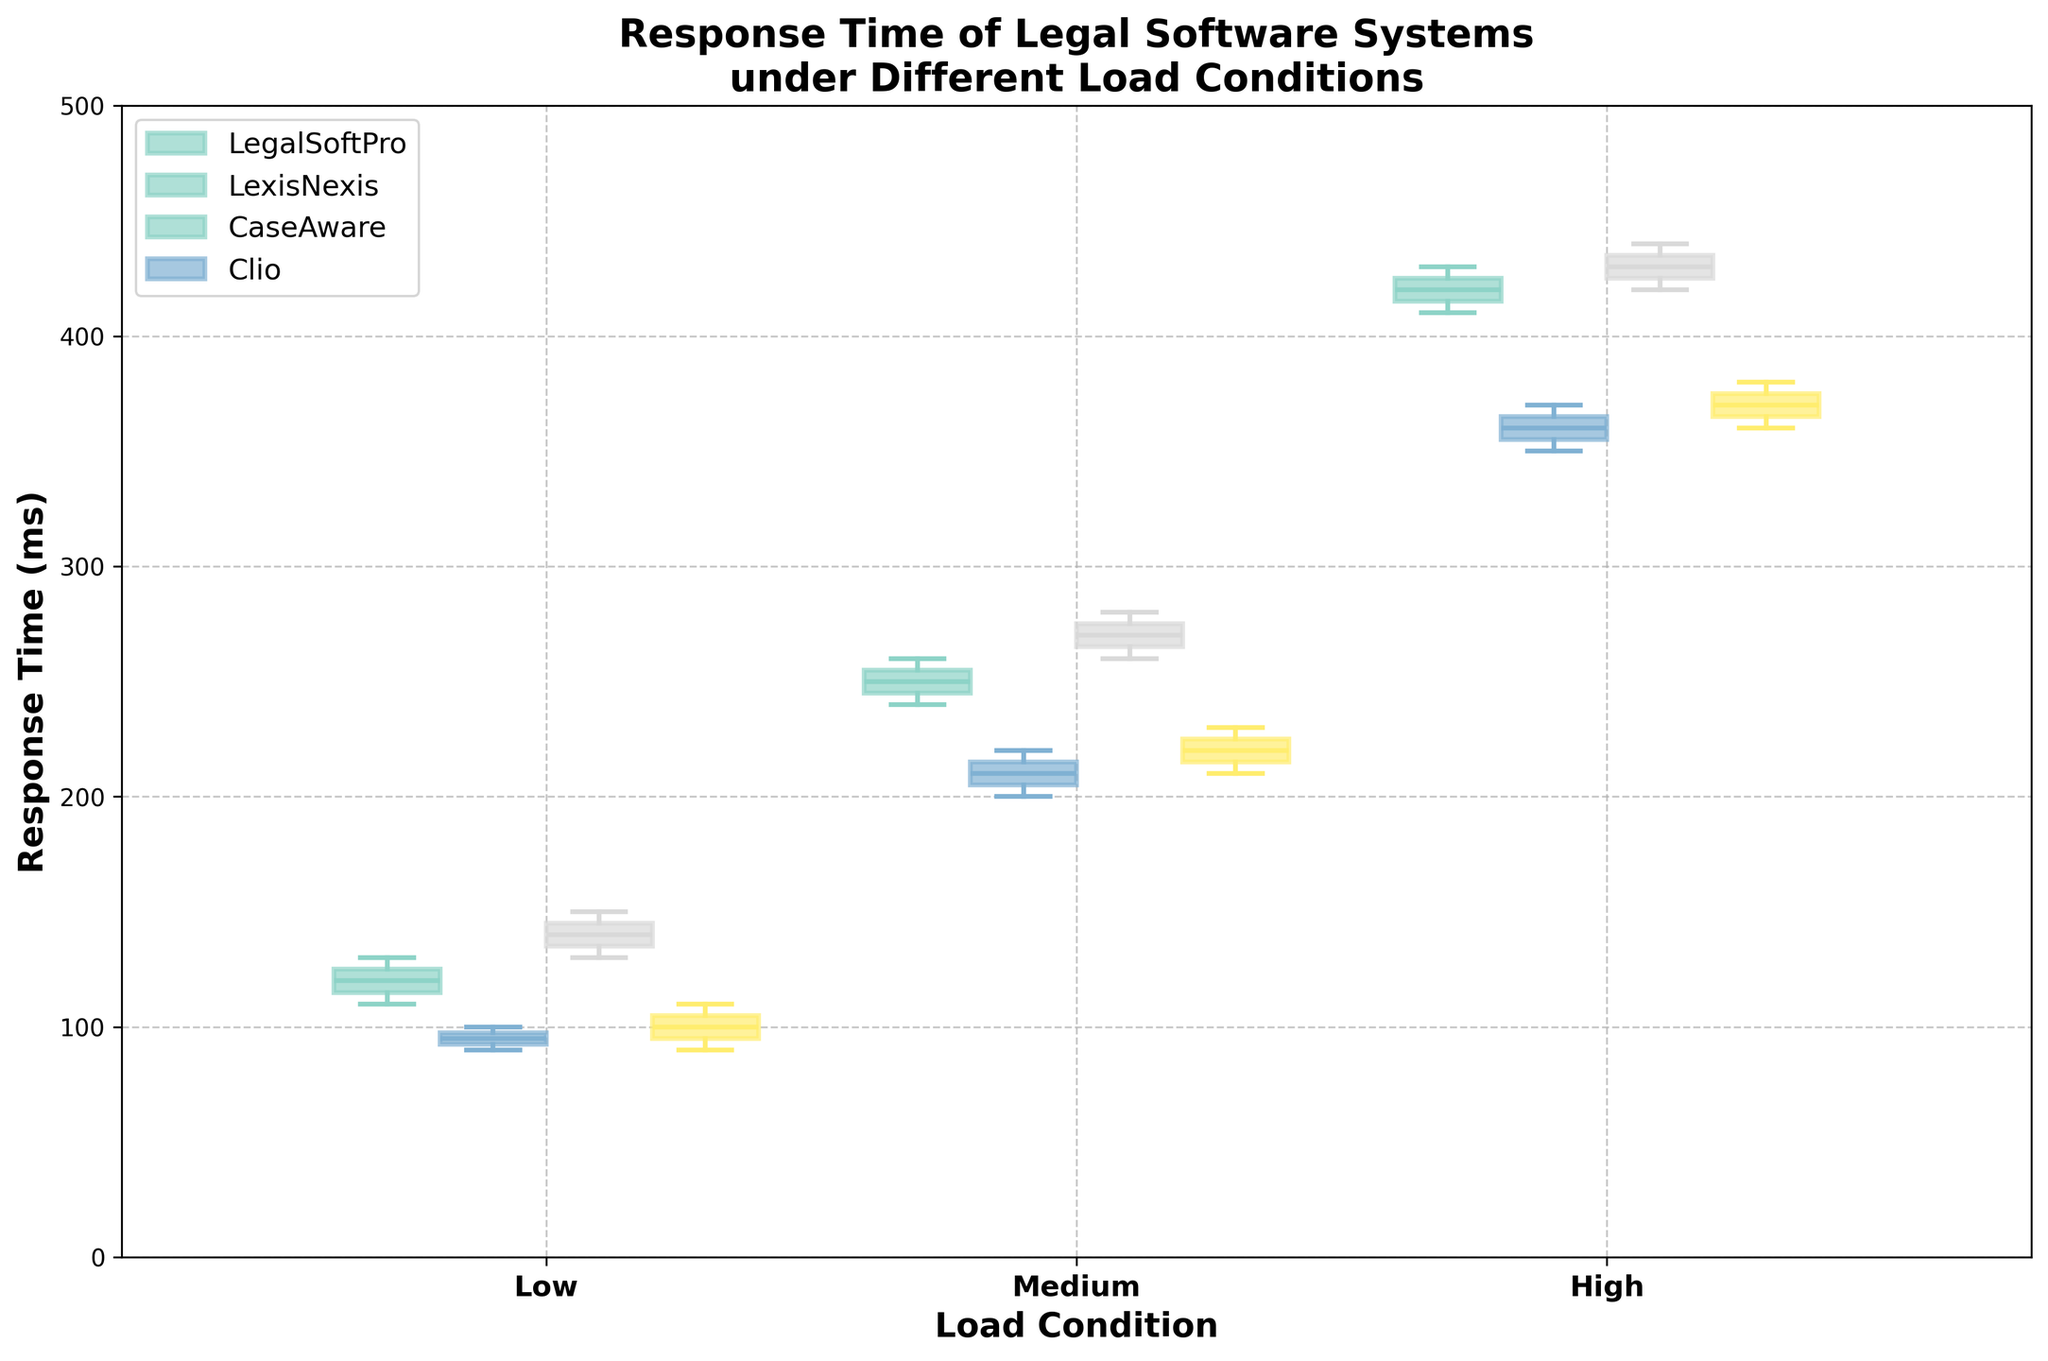How many load conditions are shown in the plot? There are three distinct load conditions shown on the x-axis: Low, Medium, and High.
Answer: 3 Which system has the lowest median response time under Low load condition? The box for LexisNexis is positioned lowest among others under Low load condition, indicating it has the lowest median response time.
Answer: LexisNexis What is the interquartile range (IQR) for LegalSoftPro under Medium load condition? The IQR is calculated by subtracting the lower quartile (Q1) from the upper quartile (Q3). For LegalSoftPro, Q1 is around 240ms and Q3 is about 260ms. The IQR is 260 - 240.
Answer: 20ms Which system shows the greatest increase in median response time from Low to High load condition? By examining the middle line of each box plot for each load condition, LegalSoftPro shows the greatest increase in height from Low to High conditions compared to others.
Answer: LegalSoftPro How do the spread of response times for CaseAware under High load condition compare to other systems? CaseAware's box plot for High load condition is larger in height relative to others, indicating a greater spread or variability in response times.
Answer: Larger spread Which system shows the most consistent response times under Medium load condition? LexisNexis has the smallest spread (i.e., shortest box) under Medium load condition, indicating the most consistent response times.
Answer: LexisNexis Is there an overlap in the response time range between Medium and High load conditions for LegalSoftPro? Upon examining, the whiskers of LegalSoftPro's Medium load box plot touch the lower whisker of the High load box plot, showing some overlap in response time ranges.
Answer: Yes Which system has the highest median response time under High load condition? By observing the position of the median line in each High load box plot, LegalSoftPro has the highest median response time among others.
Answer: LegalSoftPro What’s the difference in median response time between Clio and CaseAware under High load condition? The median lines under High load for Clio and CaseAware are around 370ms and 430ms, respectively. The difference is 430 - 370.
Answer: 60ms Has any system maintained a consistent median response time across different load conditions? No system maintains a consistent median response time as all show notable changes in the median line across Low, Medium, and High load conditions.
Answer: No 